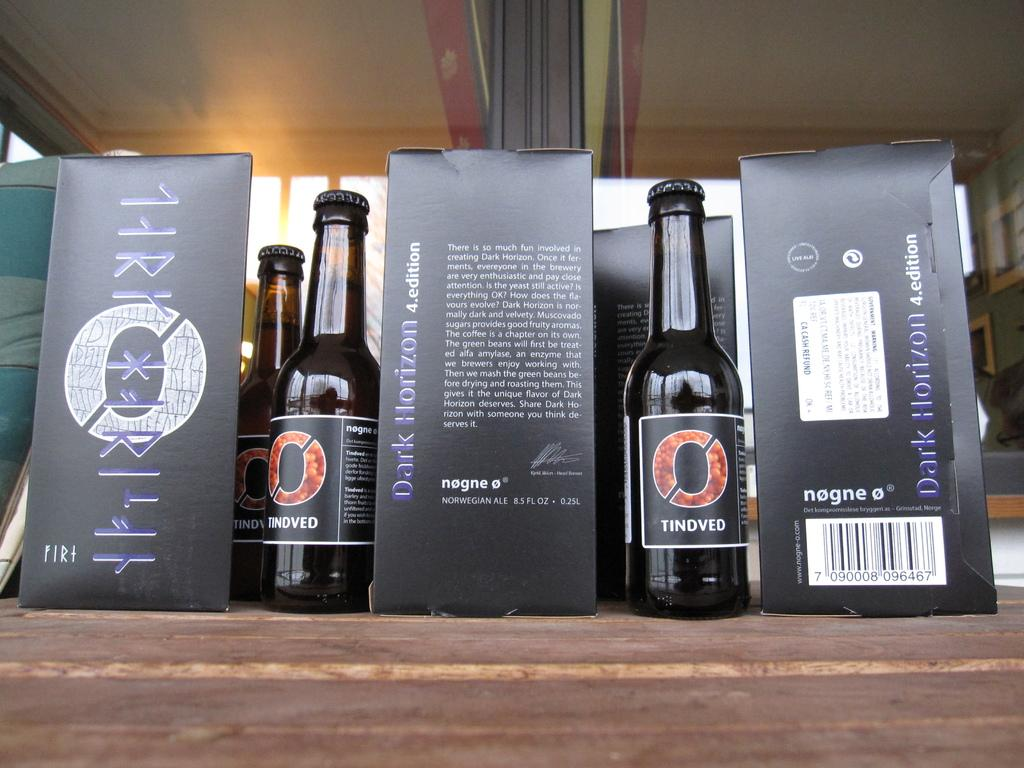<image>
Give a short and clear explanation of the subsequent image. bottles of Dark Horizon alcohol sit on a wooden surface 